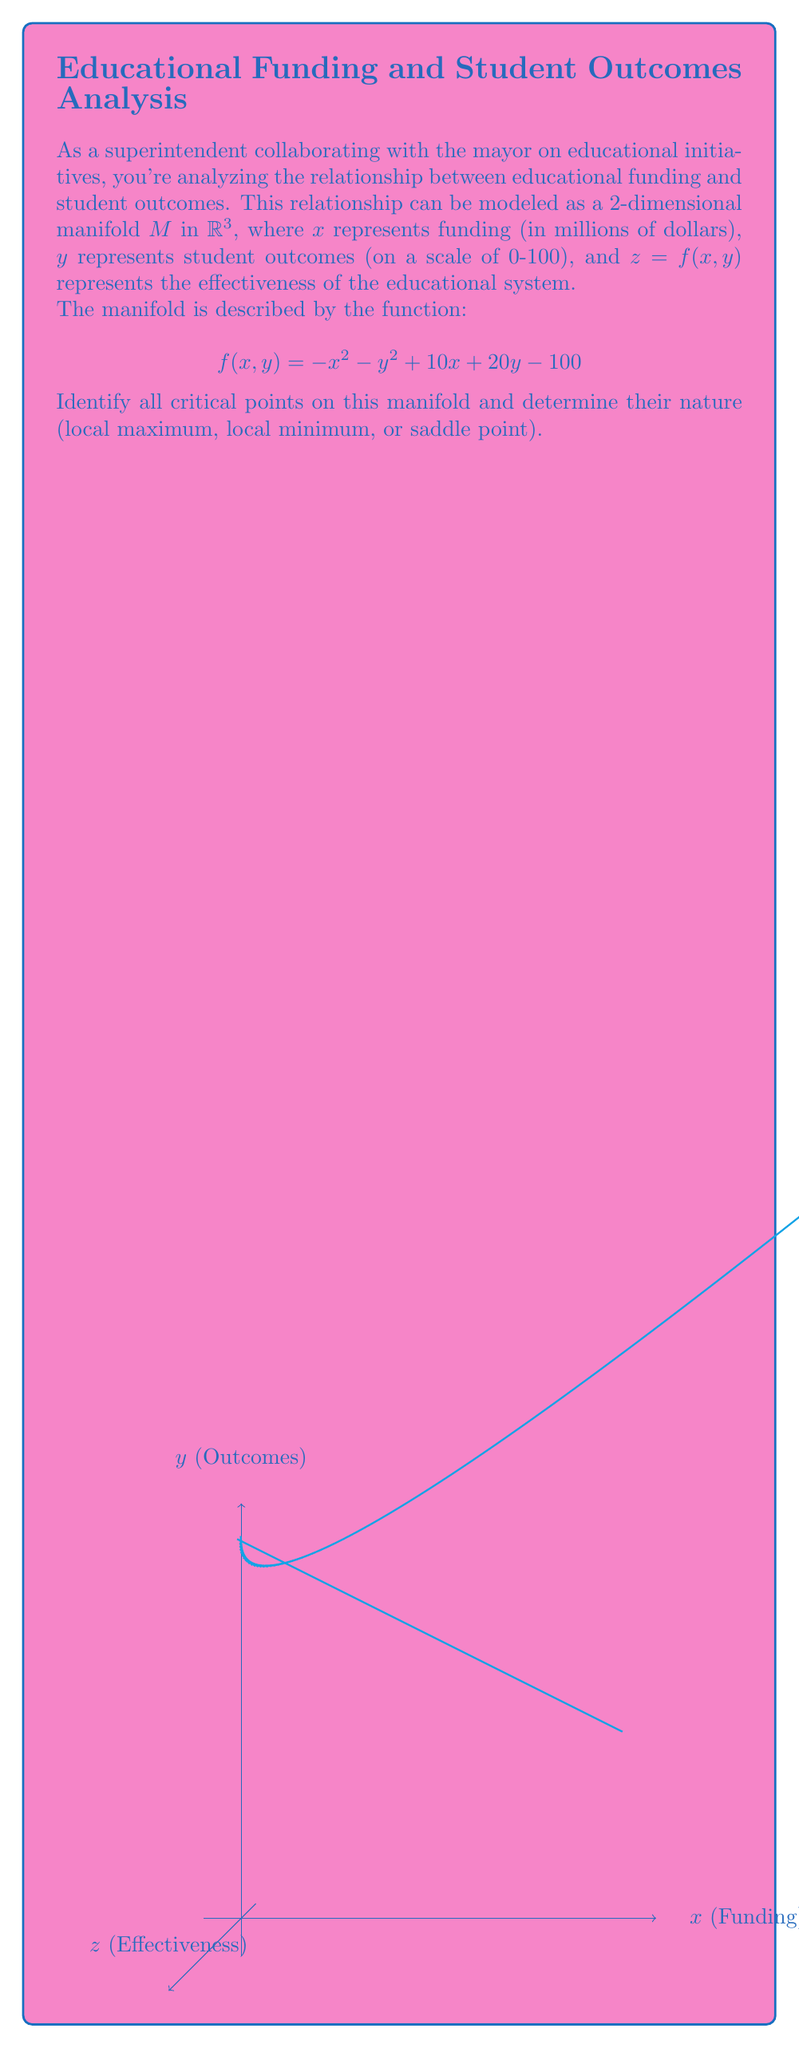Give your solution to this math problem. To find the critical points, we need to follow these steps:

1) Calculate the partial derivatives of $f$ with respect to $x$ and $y$:
   $$\frac{\partial f}{\partial x} = -2x + 10$$
   $$\frac{\partial f}{\partial y} = -2y + 20$$

2) Set both partial derivatives to zero and solve the system of equations:
   $$-2x + 10 = 0 \implies x = 5$$
   $$-2y + 20 = 0 \implies y = 10$$

   Therefore, the only critical point is (5, 10).

3) To determine the nature of this critical point, we need to calculate the second partial derivatives:
   $$\frac{\partial^2 f}{\partial x^2} = -2$$
   $$\frac{\partial^2 f}{\partial y^2} = -2$$
   $$\frac{\partial^2 f}{\partial x\partial y} = \frac{\partial^2 f}{\partial y\partial x} = 0$$

4) Now we can form the Hessian matrix:
   $$H = \begin{bmatrix} 
   -2 & 0 \\
   0 & -2
   \end{bmatrix}$$

5) The determinant of the Hessian is: $det(H) = (-2)(-2) - (0)(0) = 4 > 0$

6) Since the determinant is positive and $\frac{\partial^2 f}{\partial x^2} < 0$, this critical point is a local maximum.

7) To find the maximum value, we substitute the critical point into the original function:
   $$f(5,10) = -(5)^2 - (10)^2 + 10(5) + 20(10) - 100 = 75$$

Therefore, the manifold has a local (and global) maximum at the point (5, 10, 75), representing optimal funding of $5 million, student outcomes of 10, and a system effectiveness of 75.
Answer: One critical point: (5, 10, 75), local maximum 